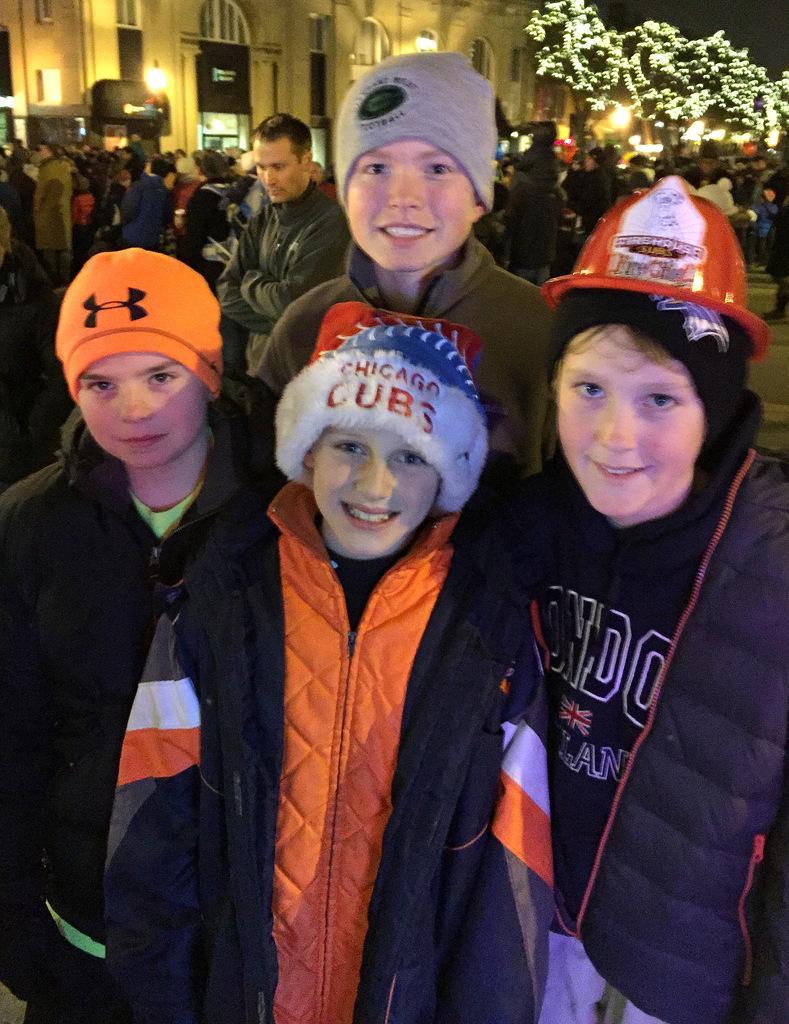Describe this image in one or two sentences. This image consists of many people. In the front, there are four persons wearing caps and jackets. In the background, there is a building along with a tree. 